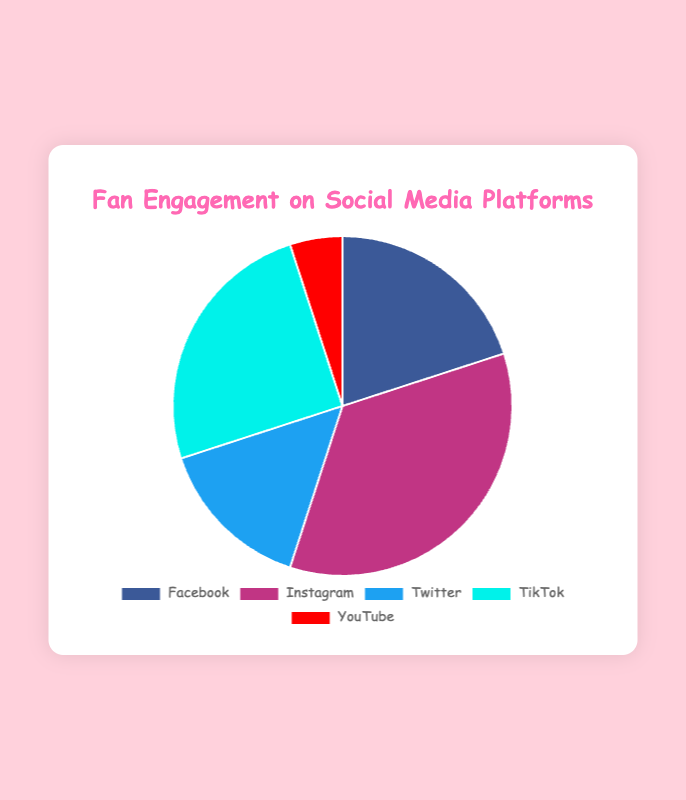What is the most popular social media platform based on fan engagement according to the pie chart? The platform with the highest percentage is the most popular one. By looking at the pie chart, Instagram has the highest percentage (35%).
Answer: Instagram Which social media platform has the least fan engagement? The platform with the lowest percentage of fan engagement is the least popular. By observing the pie chart, YouTube has the lowest engagement at 5%.
Answer: YouTube How much more fan engagement does Instagram have compared to Twitter? To find the difference in engagement, subtract Twitter's percentage (15%) from Instagram's percentage (35%): 35% - 15% = 20%.
Answer: 20% What is the combined fan engagement for Facebook and TikTok? Add the fan engagement percentages of Facebook (20%) and TikTok (25%): 20% + 25% = 45%.
Answer: 45% Which color represents Twitter in the pie chart? Identify the color associated with Twitter by looking at the specific pie slice or consulting the chart legend. The slice for Twitter is blue.
Answer: Blue How does Facebook's fan engagement compare to YouTube's? Compare their percentages to determine which is greater: Facebook (20%) has more engagement than YouTube (5%).
Answer: Facebook has more engagement If the total engagement is considered 100%, what percentage do Instagram and Twitter collectively contribute? Add the percentages of Instagram (35%) and Twitter (15%): 35% + 15% = 50%.
Answer: 50% Of Facebook, Instagram, and TikTok, which platform has the middle (median) fan engagement value? List the engagement values (Facebook: 20%, Instagram: 35%, TikTok: 25%) and find the median: Arrange 20%, 25%, 35%, so TikTok is the median.
Answer: TikTok What is the total fan engagement percentage for all platforms excluding YouTube? Add the engagement percentages for all platforms besides YouTube: Facebook (20%) + Instagram (35%) + Twitter (15%) + TikTok (25%) = 95%.
Answer: 95% 